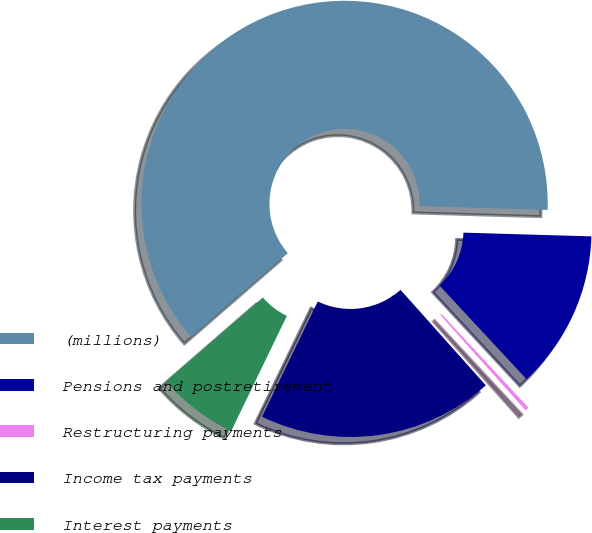<chart> <loc_0><loc_0><loc_500><loc_500><pie_chart><fcel>(millions)<fcel>Pensions and postretirement<fcel>Restructuring payments<fcel>Income tax payments<fcel>Interest payments<nl><fcel>61.84%<fcel>12.62%<fcel>0.31%<fcel>18.77%<fcel>6.46%<nl></chart> 